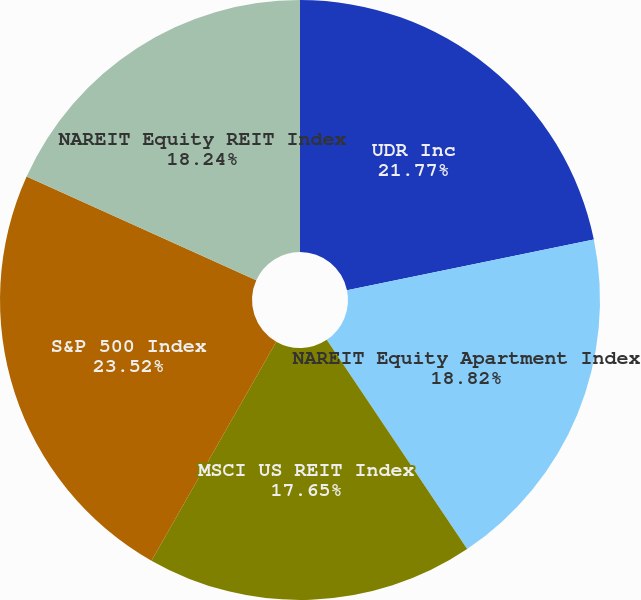<chart> <loc_0><loc_0><loc_500><loc_500><pie_chart><fcel>UDR Inc<fcel>NAREIT Equity Apartment Index<fcel>MSCI US REIT Index<fcel>S&P 500 Index<fcel>NAREIT Equity REIT Index<nl><fcel>21.77%<fcel>18.82%<fcel>17.65%<fcel>23.51%<fcel>18.24%<nl></chart> 